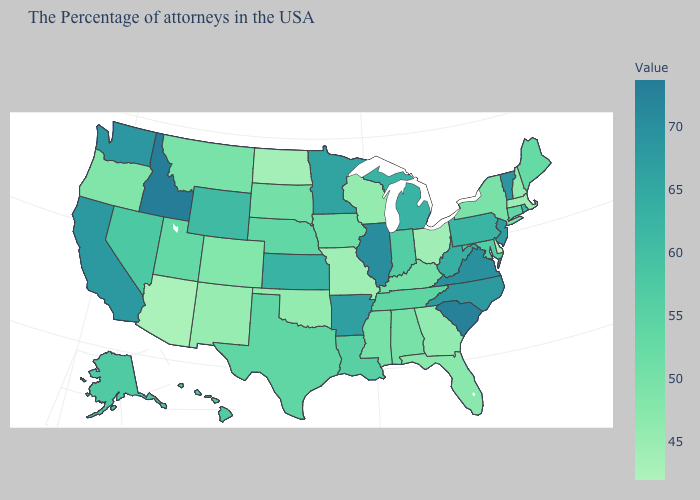Which states have the highest value in the USA?
Short answer required. Idaho. Does Idaho have the highest value in the USA?
Quick response, please. Yes. Which states have the lowest value in the West?
Concise answer only. Arizona. Does the map have missing data?
Write a very short answer. No. Does Idaho have the highest value in the USA?
Write a very short answer. Yes. 